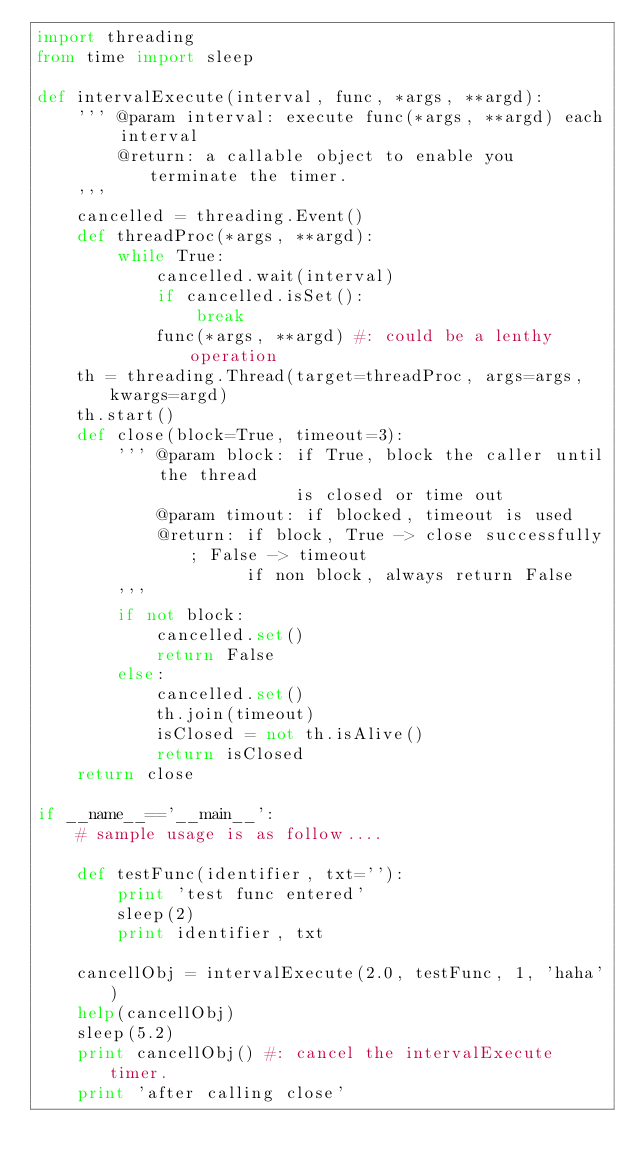<code> <loc_0><loc_0><loc_500><loc_500><_Python_>import threading
from time import sleep

def intervalExecute(interval, func, *args, **argd):
    ''' @param interval: execute func(*args, **argd) each interval
        @return: a callable object to enable you terminate the timer.
    '''
    cancelled = threading.Event()
    def threadProc(*args, **argd):
        while True:
            cancelled.wait(interval)
            if cancelled.isSet():
                break
            func(*args, **argd) #: could be a lenthy operation
    th = threading.Thread(target=threadProc, args=args, kwargs=argd)
    th.start()
    def close(block=True, timeout=3):
        ''' @param block: if True, block the caller until the thread 
                          is closed or time out
            @param timout: if blocked, timeout is used
            @return: if block, True -> close successfully; False -> timeout
                     if non block, always return False
        '''
        if not block:
            cancelled.set()
            return False
        else:
            cancelled.set()
            th.join(timeout)
            isClosed = not th.isAlive()
            return isClosed
    return close

if __name__=='__main__':
    # sample usage is as follow....
    
    def testFunc(identifier, txt=''):
        print 'test func entered'
        sleep(2)
        print identifier, txt

    cancellObj = intervalExecute(2.0, testFunc, 1, 'haha')
    help(cancellObj)
    sleep(5.2)
    print cancellObj() #: cancel the intervalExecute timer.
    print 'after calling close'
</code> 